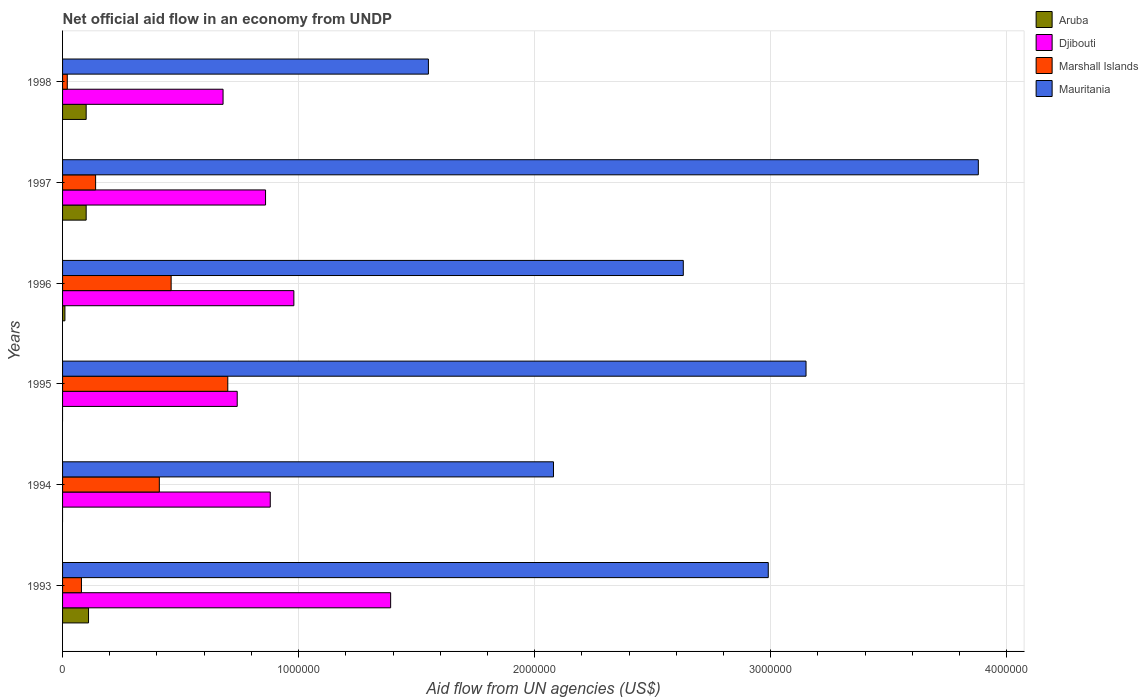How many different coloured bars are there?
Provide a succinct answer. 4. Are the number of bars on each tick of the Y-axis equal?
Give a very brief answer. No. In how many cases, is the number of bars for a given year not equal to the number of legend labels?
Make the answer very short. 2. What is the net official aid flow in Djibouti in 1994?
Give a very brief answer. 8.80e+05. Across all years, what is the maximum net official aid flow in Mauritania?
Your answer should be compact. 3.88e+06. Across all years, what is the minimum net official aid flow in Aruba?
Make the answer very short. 0. What is the total net official aid flow in Marshall Islands in the graph?
Make the answer very short. 1.81e+06. What is the difference between the net official aid flow in Marshall Islands in 1993 and that in 1994?
Keep it short and to the point. -3.30e+05. What is the difference between the net official aid flow in Mauritania in 1993 and the net official aid flow in Aruba in 1998?
Offer a very short reply. 2.89e+06. What is the average net official aid flow in Marshall Islands per year?
Your answer should be very brief. 3.02e+05. In the year 1993, what is the difference between the net official aid flow in Aruba and net official aid flow in Marshall Islands?
Give a very brief answer. 3.00e+04. What is the ratio of the net official aid flow in Djibouti in 1995 to that in 1997?
Ensure brevity in your answer.  0.86. What is the difference between the highest and the lowest net official aid flow in Djibouti?
Give a very brief answer. 7.10e+05. Is it the case that in every year, the sum of the net official aid flow in Aruba and net official aid flow in Mauritania is greater than the net official aid flow in Marshall Islands?
Your response must be concise. Yes. What is the difference between two consecutive major ticks on the X-axis?
Offer a terse response. 1.00e+06. Does the graph contain grids?
Your answer should be very brief. Yes. How many legend labels are there?
Your response must be concise. 4. What is the title of the graph?
Offer a very short reply. Net official aid flow in an economy from UNDP. Does "Sudan" appear as one of the legend labels in the graph?
Make the answer very short. No. What is the label or title of the X-axis?
Provide a succinct answer. Aid flow from UN agencies (US$). What is the label or title of the Y-axis?
Your answer should be very brief. Years. What is the Aid flow from UN agencies (US$) in Djibouti in 1993?
Your answer should be very brief. 1.39e+06. What is the Aid flow from UN agencies (US$) of Marshall Islands in 1993?
Your answer should be compact. 8.00e+04. What is the Aid flow from UN agencies (US$) in Mauritania in 1993?
Keep it short and to the point. 2.99e+06. What is the Aid flow from UN agencies (US$) in Aruba in 1994?
Provide a succinct answer. 0. What is the Aid flow from UN agencies (US$) in Djibouti in 1994?
Give a very brief answer. 8.80e+05. What is the Aid flow from UN agencies (US$) of Marshall Islands in 1994?
Keep it short and to the point. 4.10e+05. What is the Aid flow from UN agencies (US$) of Mauritania in 1994?
Your answer should be compact. 2.08e+06. What is the Aid flow from UN agencies (US$) of Djibouti in 1995?
Make the answer very short. 7.40e+05. What is the Aid flow from UN agencies (US$) in Mauritania in 1995?
Your answer should be very brief. 3.15e+06. What is the Aid flow from UN agencies (US$) in Djibouti in 1996?
Provide a succinct answer. 9.80e+05. What is the Aid flow from UN agencies (US$) of Marshall Islands in 1996?
Make the answer very short. 4.60e+05. What is the Aid flow from UN agencies (US$) of Mauritania in 1996?
Your response must be concise. 2.63e+06. What is the Aid flow from UN agencies (US$) in Djibouti in 1997?
Ensure brevity in your answer.  8.60e+05. What is the Aid flow from UN agencies (US$) in Marshall Islands in 1997?
Offer a very short reply. 1.40e+05. What is the Aid flow from UN agencies (US$) in Mauritania in 1997?
Your answer should be compact. 3.88e+06. What is the Aid flow from UN agencies (US$) of Aruba in 1998?
Give a very brief answer. 1.00e+05. What is the Aid flow from UN agencies (US$) of Djibouti in 1998?
Give a very brief answer. 6.80e+05. What is the Aid flow from UN agencies (US$) in Mauritania in 1998?
Make the answer very short. 1.55e+06. Across all years, what is the maximum Aid flow from UN agencies (US$) of Aruba?
Ensure brevity in your answer.  1.10e+05. Across all years, what is the maximum Aid flow from UN agencies (US$) of Djibouti?
Keep it short and to the point. 1.39e+06. Across all years, what is the maximum Aid flow from UN agencies (US$) of Marshall Islands?
Ensure brevity in your answer.  7.00e+05. Across all years, what is the maximum Aid flow from UN agencies (US$) in Mauritania?
Give a very brief answer. 3.88e+06. Across all years, what is the minimum Aid flow from UN agencies (US$) in Aruba?
Ensure brevity in your answer.  0. Across all years, what is the minimum Aid flow from UN agencies (US$) of Djibouti?
Offer a very short reply. 6.80e+05. Across all years, what is the minimum Aid flow from UN agencies (US$) of Marshall Islands?
Give a very brief answer. 2.00e+04. Across all years, what is the minimum Aid flow from UN agencies (US$) of Mauritania?
Your answer should be very brief. 1.55e+06. What is the total Aid flow from UN agencies (US$) of Djibouti in the graph?
Your answer should be compact. 5.53e+06. What is the total Aid flow from UN agencies (US$) of Marshall Islands in the graph?
Give a very brief answer. 1.81e+06. What is the total Aid flow from UN agencies (US$) in Mauritania in the graph?
Your response must be concise. 1.63e+07. What is the difference between the Aid flow from UN agencies (US$) in Djibouti in 1993 and that in 1994?
Provide a short and direct response. 5.10e+05. What is the difference between the Aid flow from UN agencies (US$) of Marshall Islands in 1993 and that in 1994?
Make the answer very short. -3.30e+05. What is the difference between the Aid flow from UN agencies (US$) of Mauritania in 1993 and that in 1994?
Your response must be concise. 9.10e+05. What is the difference between the Aid flow from UN agencies (US$) of Djibouti in 1993 and that in 1995?
Make the answer very short. 6.50e+05. What is the difference between the Aid flow from UN agencies (US$) of Marshall Islands in 1993 and that in 1995?
Offer a terse response. -6.20e+05. What is the difference between the Aid flow from UN agencies (US$) of Aruba in 1993 and that in 1996?
Ensure brevity in your answer.  1.00e+05. What is the difference between the Aid flow from UN agencies (US$) of Djibouti in 1993 and that in 1996?
Your response must be concise. 4.10e+05. What is the difference between the Aid flow from UN agencies (US$) in Marshall Islands in 1993 and that in 1996?
Your answer should be very brief. -3.80e+05. What is the difference between the Aid flow from UN agencies (US$) of Mauritania in 1993 and that in 1996?
Ensure brevity in your answer.  3.60e+05. What is the difference between the Aid flow from UN agencies (US$) in Aruba in 1993 and that in 1997?
Provide a succinct answer. 10000. What is the difference between the Aid flow from UN agencies (US$) in Djibouti in 1993 and that in 1997?
Provide a short and direct response. 5.30e+05. What is the difference between the Aid flow from UN agencies (US$) of Marshall Islands in 1993 and that in 1997?
Your answer should be very brief. -6.00e+04. What is the difference between the Aid flow from UN agencies (US$) of Mauritania in 1993 and that in 1997?
Keep it short and to the point. -8.90e+05. What is the difference between the Aid flow from UN agencies (US$) in Djibouti in 1993 and that in 1998?
Keep it short and to the point. 7.10e+05. What is the difference between the Aid flow from UN agencies (US$) of Mauritania in 1993 and that in 1998?
Your answer should be compact. 1.44e+06. What is the difference between the Aid flow from UN agencies (US$) in Djibouti in 1994 and that in 1995?
Keep it short and to the point. 1.40e+05. What is the difference between the Aid flow from UN agencies (US$) in Marshall Islands in 1994 and that in 1995?
Your answer should be compact. -2.90e+05. What is the difference between the Aid flow from UN agencies (US$) of Mauritania in 1994 and that in 1995?
Offer a very short reply. -1.07e+06. What is the difference between the Aid flow from UN agencies (US$) of Marshall Islands in 1994 and that in 1996?
Offer a very short reply. -5.00e+04. What is the difference between the Aid flow from UN agencies (US$) of Mauritania in 1994 and that in 1996?
Provide a short and direct response. -5.50e+05. What is the difference between the Aid flow from UN agencies (US$) in Marshall Islands in 1994 and that in 1997?
Offer a terse response. 2.70e+05. What is the difference between the Aid flow from UN agencies (US$) in Mauritania in 1994 and that in 1997?
Make the answer very short. -1.80e+06. What is the difference between the Aid flow from UN agencies (US$) of Djibouti in 1994 and that in 1998?
Give a very brief answer. 2.00e+05. What is the difference between the Aid flow from UN agencies (US$) of Marshall Islands in 1994 and that in 1998?
Your answer should be compact. 3.90e+05. What is the difference between the Aid flow from UN agencies (US$) of Mauritania in 1994 and that in 1998?
Keep it short and to the point. 5.30e+05. What is the difference between the Aid flow from UN agencies (US$) in Marshall Islands in 1995 and that in 1996?
Your answer should be compact. 2.40e+05. What is the difference between the Aid flow from UN agencies (US$) of Mauritania in 1995 and that in 1996?
Make the answer very short. 5.20e+05. What is the difference between the Aid flow from UN agencies (US$) in Marshall Islands in 1995 and that in 1997?
Offer a terse response. 5.60e+05. What is the difference between the Aid flow from UN agencies (US$) in Mauritania in 1995 and that in 1997?
Give a very brief answer. -7.30e+05. What is the difference between the Aid flow from UN agencies (US$) of Marshall Islands in 1995 and that in 1998?
Offer a very short reply. 6.80e+05. What is the difference between the Aid flow from UN agencies (US$) in Mauritania in 1995 and that in 1998?
Your response must be concise. 1.60e+06. What is the difference between the Aid flow from UN agencies (US$) in Aruba in 1996 and that in 1997?
Offer a terse response. -9.00e+04. What is the difference between the Aid flow from UN agencies (US$) of Djibouti in 1996 and that in 1997?
Provide a succinct answer. 1.20e+05. What is the difference between the Aid flow from UN agencies (US$) of Mauritania in 1996 and that in 1997?
Keep it short and to the point. -1.25e+06. What is the difference between the Aid flow from UN agencies (US$) of Djibouti in 1996 and that in 1998?
Give a very brief answer. 3.00e+05. What is the difference between the Aid flow from UN agencies (US$) of Marshall Islands in 1996 and that in 1998?
Your answer should be compact. 4.40e+05. What is the difference between the Aid flow from UN agencies (US$) in Mauritania in 1996 and that in 1998?
Offer a terse response. 1.08e+06. What is the difference between the Aid flow from UN agencies (US$) in Aruba in 1997 and that in 1998?
Your answer should be very brief. 0. What is the difference between the Aid flow from UN agencies (US$) of Mauritania in 1997 and that in 1998?
Provide a succinct answer. 2.33e+06. What is the difference between the Aid flow from UN agencies (US$) in Aruba in 1993 and the Aid flow from UN agencies (US$) in Djibouti in 1994?
Offer a terse response. -7.70e+05. What is the difference between the Aid flow from UN agencies (US$) of Aruba in 1993 and the Aid flow from UN agencies (US$) of Mauritania in 1994?
Provide a short and direct response. -1.97e+06. What is the difference between the Aid flow from UN agencies (US$) in Djibouti in 1993 and the Aid flow from UN agencies (US$) in Marshall Islands in 1994?
Offer a very short reply. 9.80e+05. What is the difference between the Aid flow from UN agencies (US$) in Djibouti in 1993 and the Aid flow from UN agencies (US$) in Mauritania in 1994?
Provide a short and direct response. -6.90e+05. What is the difference between the Aid flow from UN agencies (US$) in Aruba in 1993 and the Aid flow from UN agencies (US$) in Djibouti in 1995?
Offer a terse response. -6.30e+05. What is the difference between the Aid flow from UN agencies (US$) of Aruba in 1993 and the Aid flow from UN agencies (US$) of Marshall Islands in 1995?
Your response must be concise. -5.90e+05. What is the difference between the Aid flow from UN agencies (US$) of Aruba in 1993 and the Aid flow from UN agencies (US$) of Mauritania in 1995?
Your response must be concise. -3.04e+06. What is the difference between the Aid flow from UN agencies (US$) of Djibouti in 1993 and the Aid flow from UN agencies (US$) of Marshall Islands in 1995?
Your answer should be compact. 6.90e+05. What is the difference between the Aid flow from UN agencies (US$) in Djibouti in 1993 and the Aid flow from UN agencies (US$) in Mauritania in 1995?
Provide a succinct answer. -1.76e+06. What is the difference between the Aid flow from UN agencies (US$) in Marshall Islands in 1993 and the Aid flow from UN agencies (US$) in Mauritania in 1995?
Your answer should be compact. -3.07e+06. What is the difference between the Aid flow from UN agencies (US$) of Aruba in 1993 and the Aid flow from UN agencies (US$) of Djibouti in 1996?
Your answer should be compact. -8.70e+05. What is the difference between the Aid flow from UN agencies (US$) in Aruba in 1993 and the Aid flow from UN agencies (US$) in Marshall Islands in 1996?
Provide a short and direct response. -3.50e+05. What is the difference between the Aid flow from UN agencies (US$) of Aruba in 1993 and the Aid flow from UN agencies (US$) of Mauritania in 1996?
Provide a succinct answer. -2.52e+06. What is the difference between the Aid flow from UN agencies (US$) in Djibouti in 1993 and the Aid flow from UN agencies (US$) in Marshall Islands in 1996?
Make the answer very short. 9.30e+05. What is the difference between the Aid flow from UN agencies (US$) of Djibouti in 1993 and the Aid flow from UN agencies (US$) of Mauritania in 1996?
Your response must be concise. -1.24e+06. What is the difference between the Aid flow from UN agencies (US$) in Marshall Islands in 1993 and the Aid flow from UN agencies (US$) in Mauritania in 1996?
Your response must be concise. -2.55e+06. What is the difference between the Aid flow from UN agencies (US$) in Aruba in 1993 and the Aid flow from UN agencies (US$) in Djibouti in 1997?
Offer a terse response. -7.50e+05. What is the difference between the Aid flow from UN agencies (US$) in Aruba in 1993 and the Aid flow from UN agencies (US$) in Marshall Islands in 1997?
Provide a succinct answer. -3.00e+04. What is the difference between the Aid flow from UN agencies (US$) of Aruba in 1993 and the Aid flow from UN agencies (US$) of Mauritania in 1997?
Ensure brevity in your answer.  -3.77e+06. What is the difference between the Aid flow from UN agencies (US$) of Djibouti in 1993 and the Aid flow from UN agencies (US$) of Marshall Islands in 1997?
Keep it short and to the point. 1.25e+06. What is the difference between the Aid flow from UN agencies (US$) in Djibouti in 1993 and the Aid flow from UN agencies (US$) in Mauritania in 1997?
Your response must be concise. -2.49e+06. What is the difference between the Aid flow from UN agencies (US$) of Marshall Islands in 1993 and the Aid flow from UN agencies (US$) of Mauritania in 1997?
Offer a terse response. -3.80e+06. What is the difference between the Aid flow from UN agencies (US$) of Aruba in 1993 and the Aid flow from UN agencies (US$) of Djibouti in 1998?
Ensure brevity in your answer.  -5.70e+05. What is the difference between the Aid flow from UN agencies (US$) in Aruba in 1993 and the Aid flow from UN agencies (US$) in Marshall Islands in 1998?
Offer a very short reply. 9.00e+04. What is the difference between the Aid flow from UN agencies (US$) in Aruba in 1993 and the Aid flow from UN agencies (US$) in Mauritania in 1998?
Your answer should be very brief. -1.44e+06. What is the difference between the Aid flow from UN agencies (US$) in Djibouti in 1993 and the Aid flow from UN agencies (US$) in Marshall Islands in 1998?
Give a very brief answer. 1.37e+06. What is the difference between the Aid flow from UN agencies (US$) of Marshall Islands in 1993 and the Aid flow from UN agencies (US$) of Mauritania in 1998?
Provide a succinct answer. -1.47e+06. What is the difference between the Aid flow from UN agencies (US$) of Djibouti in 1994 and the Aid flow from UN agencies (US$) of Mauritania in 1995?
Offer a very short reply. -2.27e+06. What is the difference between the Aid flow from UN agencies (US$) in Marshall Islands in 1994 and the Aid flow from UN agencies (US$) in Mauritania in 1995?
Your answer should be compact. -2.74e+06. What is the difference between the Aid flow from UN agencies (US$) of Djibouti in 1994 and the Aid flow from UN agencies (US$) of Mauritania in 1996?
Give a very brief answer. -1.75e+06. What is the difference between the Aid flow from UN agencies (US$) in Marshall Islands in 1994 and the Aid flow from UN agencies (US$) in Mauritania in 1996?
Your answer should be very brief. -2.22e+06. What is the difference between the Aid flow from UN agencies (US$) in Djibouti in 1994 and the Aid flow from UN agencies (US$) in Marshall Islands in 1997?
Offer a terse response. 7.40e+05. What is the difference between the Aid flow from UN agencies (US$) of Marshall Islands in 1994 and the Aid flow from UN agencies (US$) of Mauritania in 1997?
Ensure brevity in your answer.  -3.47e+06. What is the difference between the Aid flow from UN agencies (US$) of Djibouti in 1994 and the Aid flow from UN agencies (US$) of Marshall Islands in 1998?
Provide a succinct answer. 8.60e+05. What is the difference between the Aid flow from UN agencies (US$) in Djibouti in 1994 and the Aid flow from UN agencies (US$) in Mauritania in 1998?
Offer a very short reply. -6.70e+05. What is the difference between the Aid flow from UN agencies (US$) of Marshall Islands in 1994 and the Aid flow from UN agencies (US$) of Mauritania in 1998?
Your response must be concise. -1.14e+06. What is the difference between the Aid flow from UN agencies (US$) in Djibouti in 1995 and the Aid flow from UN agencies (US$) in Marshall Islands in 1996?
Provide a succinct answer. 2.80e+05. What is the difference between the Aid flow from UN agencies (US$) of Djibouti in 1995 and the Aid flow from UN agencies (US$) of Mauritania in 1996?
Your answer should be very brief. -1.89e+06. What is the difference between the Aid flow from UN agencies (US$) of Marshall Islands in 1995 and the Aid flow from UN agencies (US$) of Mauritania in 1996?
Keep it short and to the point. -1.93e+06. What is the difference between the Aid flow from UN agencies (US$) in Djibouti in 1995 and the Aid flow from UN agencies (US$) in Mauritania in 1997?
Provide a succinct answer. -3.14e+06. What is the difference between the Aid flow from UN agencies (US$) of Marshall Islands in 1995 and the Aid flow from UN agencies (US$) of Mauritania in 1997?
Give a very brief answer. -3.18e+06. What is the difference between the Aid flow from UN agencies (US$) in Djibouti in 1995 and the Aid flow from UN agencies (US$) in Marshall Islands in 1998?
Ensure brevity in your answer.  7.20e+05. What is the difference between the Aid flow from UN agencies (US$) in Djibouti in 1995 and the Aid flow from UN agencies (US$) in Mauritania in 1998?
Offer a very short reply. -8.10e+05. What is the difference between the Aid flow from UN agencies (US$) of Marshall Islands in 1995 and the Aid flow from UN agencies (US$) of Mauritania in 1998?
Provide a short and direct response. -8.50e+05. What is the difference between the Aid flow from UN agencies (US$) in Aruba in 1996 and the Aid flow from UN agencies (US$) in Djibouti in 1997?
Your response must be concise. -8.50e+05. What is the difference between the Aid flow from UN agencies (US$) in Aruba in 1996 and the Aid flow from UN agencies (US$) in Mauritania in 1997?
Offer a very short reply. -3.87e+06. What is the difference between the Aid flow from UN agencies (US$) of Djibouti in 1996 and the Aid flow from UN agencies (US$) of Marshall Islands in 1997?
Keep it short and to the point. 8.40e+05. What is the difference between the Aid flow from UN agencies (US$) in Djibouti in 1996 and the Aid flow from UN agencies (US$) in Mauritania in 1997?
Ensure brevity in your answer.  -2.90e+06. What is the difference between the Aid flow from UN agencies (US$) in Marshall Islands in 1996 and the Aid flow from UN agencies (US$) in Mauritania in 1997?
Provide a short and direct response. -3.42e+06. What is the difference between the Aid flow from UN agencies (US$) of Aruba in 1996 and the Aid flow from UN agencies (US$) of Djibouti in 1998?
Give a very brief answer. -6.70e+05. What is the difference between the Aid flow from UN agencies (US$) in Aruba in 1996 and the Aid flow from UN agencies (US$) in Mauritania in 1998?
Provide a short and direct response. -1.54e+06. What is the difference between the Aid flow from UN agencies (US$) of Djibouti in 1996 and the Aid flow from UN agencies (US$) of Marshall Islands in 1998?
Your answer should be very brief. 9.60e+05. What is the difference between the Aid flow from UN agencies (US$) of Djibouti in 1996 and the Aid flow from UN agencies (US$) of Mauritania in 1998?
Give a very brief answer. -5.70e+05. What is the difference between the Aid flow from UN agencies (US$) of Marshall Islands in 1996 and the Aid flow from UN agencies (US$) of Mauritania in 1998?
Make the answer very short. -1.09e+06. What is the difference between the Aid flow from UN agencies (US$) of Aruba in 1997 and the Aid flow from UN agencies (US$) of Djibouti in 1998?
Provide a short and direct response. -5.80e+05. What is the difference between the Aid flow from UN agencies (US$) in Aruba in 1997 and the Aid flow from UN agencies (US$) in Marshall Islands in 1998?
Give a very brief answer. 8.00e+04. What is the difference between the Aid flow from UN agencies (US$) of Aruba in 1997 and the Aid flow from UN agencies (US$) of Mauritania in 1998?
Keep it short and to the point. -1.45e+06. What is the difference between the Aid flow from UN agencies (US$) in Djibouti in 1997 and the Aid flow from UN agencies (US$) in Marshall Islands in 1998?
Make the answer very short. 8.40e+05. What is the difference between the Aid flow from UN agencies (US$) of Djibouti in 1997 and the Aid flow from UN agencies (US$) of Mauritania in 1998?
Your response must be concise. -6.90e+05. What is the difference between the Aid flow from UN agencies (US$) of Marshall Islands in 1997 and the Aid flow from UN agencies (US$) of Mauritania in 1998?
Offer a terse response. -1.41e+06. What is the average Aid flow from UN agencies (US$) in Aruba per year?
Your answer should be very brief. 5.33e+04. What is the average Aid flow from UN agencies (US$) in Djibouti per year?
Offer a very short reply. 9.22e+05. What is the average Aid flow from UN agencies (US$) in Marshall Islands per year?
Make the answer very short. 3.02e+05. What is the average Aid flow from UN agencies (US$) in Mauritania per year?
Offer a very short reply. 2.71e+06. In the year 1993, what is the difference between the Aid flow from UN agencies (US$) of Aruba and Aid flow from UN agencies (US$) of Djibouti?
Your answer should be compact. -1.28e+06. In the year 1993, what is the difference between the Aid flow from UN agencies (US$) of Aruba and Aid flow from UN agencies (US$) of Marshall Islands?
Your answer should be compact. 3.00e+04. In the year 1993, what is the difference between the Aid flow from UN agencies (US$) of Aruba and Aid flow from UN agencies (US$) of Mauritania?
Give a very brief answer. -2.88e+06. In the year 1993, what is the difference between the Aid flow from UN agencies (US$) of Djibouti and Aid flow from UN agencies (US$) of Marshall Islands?
Your answer should be very brief. 1.31e+06. In the year 1993, what is the difference between the Aid flow from UN agencies (US$) in Djibouti and Aid flow from UN agencies (US$) in Mauritania?
Offer a very short reply. -1.60e+06. In the year 1993, what is the difference between the Aid flow from UN agencies (US$) of Marshall Islands and Aid flow from UN agencies (US$) of Mauritania?
Make the answer very short. -2.91e+06. In the year 1994, what is the difference between the Aid flow from UN agencies (US$) of Djibouti and Aid flow from UN agencies (US$) of Mauritania?
Offer a terse response. -1.20e+06. In the year 1994, what is the difference between the Aid flow from UN agencies (US$) of Marshall Islands and Aid flow from UN agencies (US$) of Mauritania?
Provide a succinct answer. -1.67e+06. In the year 1995, what is the difference between the Aid flow from UN agencies (US$) in Djibouti and Aid flow from UN agencies (US$) in Mauritania?
Ensure brevity in your answer.  -2.41e+06. In the year 1995, what is the difference between the Aid flow from UN agencies (US$) of Marshall Islands and Aid flow from UN agencies (US$) of Mauritania?
Keep it short and to the point. -2.45e+06. In the year 1996, what is the difference between the Aid flow from UN agencies (US$) of Aruba and Aid flow from UN agencies (US$) of Djibouti?
Your response must be concise. -9.70e+05. In the year 1996, what is the difference between the Aid flow from UN agencies (US$) in Aruba and Aid flow from UN agencies (US$) in Marshall Islands?
Provide a short and direct response. -4.50e+05. In the year 1996, what is the difference between the Aid flow from UN agencies (US$) in Aruba and Aid flow from UN agencies (US$) in Mauritania?
Your answer should be compact. -2.62e+06. In the year 1996, what is the difference between the Aid flow from UN agencies (US$) of Djibouti and Aid flow from UN agencies (US$) of Marshall Islands?
Ensure brevity in your answer.  5.20e+05. In the year 1996, what is the difference between the Aid flow from UN agencies (US$) of Djibouti and Aid flow from UN agencies (US$) of Mauritania?
Your response must be concise. -1.65e+06. In the year 1996, what is the difference between the Aid flow from UN agencies (US$) in Marshall Islands and Aid flow from UN agencies (US$) in Mauritania?
Provide a succinct answer. -2.17e+06. In the year 1997, what is the difference between the Aid flow from UN agencies (US$) of Aruba and Aid flow from UN agencies (US$) of Djibouti?
Provide a short and direct response. -7.60e+05. In the year 1997, what is the difference between the Aid flow from UN agencies (US$) of Aruba and Aid flow from UN agencies (US$) of Mauritania?
Ensure brevity in your answer.  -3.78e+06. In the year 1997, what is the difference between the Aid flow from UN agencies (US$) of Djibouti and Aid flow from UN agencies (US$) of Marshall Islands?
Keep it short and to the point. 7.20e+05. In the year 1997, what is the difference between the Aid flow from UN agencies (US$) of Djibouti and Aid flow from UN agencies (US$) of Mauritania?
Provide a succinct answer. -3.02e+06. In the year 1997, what is the difference between the Aid flow from UN agencies (US$) of Marshall Islands and Aid flow from UN agencies (US$) of Mauritania?
Your response must be concise. -3.74e+06. In the year 1998, what is the difference between the Aid flow from UN agencies (US$) of Aruba and Aid flow from UN agencies (US$) of Djibouti?
Provide a short and direct response. -5.80e+05. In the year 1998, what is the difference between the Aid flow from UN agencies (US$) of Aruba and Aid flow from UN agencies (US$) of Mauritania?
Make the answer very short. -1.45e+06. In the year 1998, what is the difference between the Aid flow from UN agencies (US$) of Djibouti and Aid flow from UN agencies (US$) of Marshall Islands?
Give a very brief answer. 6.60e+05. In the year 1998, what is the difference between the Aid flow from UN agencies (US$) in Djibouti and Aid flow from UN agencies (US$) in Mauritania?
Your response must be concise. -8.70e+05. In the year 1998, what is the difference between the Aid flow from UN agencies (US$) of Marshall Islands and Aid flow from UN agencies (US$) of Mauritania?
Keep it short and to the point. -1.53e+06. What is the ratio of the Aid flow from UN agencies (US$) in Djibouti in 1993 to that in 1994?
Keep it short and to the point. 1.58. What is the ratio of the Aid flow from UN agencies (US$) of Marshall Islands in 1993 to that in 1994?
Give a very brief answer. 0.2. What is the ratio of the Aid flow from UN agencies (US$) of Mauritania in 1993 to that in 1994?
Provide a short and direct response. 1.44. What is the ratio of the Aid flow from UN agencies (US$) of Djibouti in 1993 to that in 1995?
Your answer should be compact. 1.88. What is the ratio of the Aid flow from UN agencies (US$) in Marshall Islands in 1993 to that in 1995?
Your answer should be very brief. 0.11. What is the ratio of the Aid flow from UN agencies (US$) of Mauritania in 1993 to that in 1995?
Ensure brevity in your answer.  0.95. What is the ratio of the Aid flow from UN agencies (US$) of Aruba in 1993 to that in 1996?
Provide a succinct answer. 11. What is the ratio of the Aid flow from UN agencies (US$) of Djibouti in 1993 to that in 1996?
Your answer should be compact. 1.42. What is the ratio of the Aid flow from UN agencies (US$) in Marshall Islands in 1993 to that in 1996?
Your response must be concise. 0.17. What is the ratio of the Aid flow from UN agencies (US$) in Mauritania in 1993 to that in 1996?
Ensure brevity in your answer.  1.14. What is the ratio of the Aid flow from UN agencies (US$) of Djibouti in 1993 to that in 1997?
Your answer should be compact. 1.62. What is the ratio of the Aid flow from UN agencies (US$) of Mauritania in 1993 to that in 1997?
Your response must be concise. 0.77. What is the ratio of the Aid flow from UN agencies (US$) in Djibouti in 1993 to that in 1998?
Offer a very short reply. 2.04. What is the ratio of the Aid flow from UN agencies (US$) of Marshall Islands in 1993 to that in 1998?
Offer a very short reply. 4. What is the ratio of the Aid flow from UN agencies (US$) of Mauritania in 1993 to that in 1998?
Your answer should be very brief. 1.93. What is the ratio of the Aid flow from UN agencies (US$) of Djibouti in 1994 to that in 1995?
Ensure brevity in your answer.  1.19. What is the ratio of the Aid flow from UN agencies (US$) of Marshall Islands in 1994 to that in 1995?
Offer a terse response. 0.59. What is the ratio of the Aid flow from UN agencies (US$) in Mauritania in 1994 to that in 1995?
Your answer should be very brief. 0.66. What is the ratio of the Aid flow from UN agencies (US$) in Djibouti in 1994 to that in 1996?
Your answer should be very brief. 0.9. What is the ratio of the Aid flow from UN agencies (US$) of Marshall Islands in 1994 to that in 1996?
Keep it short and to the point. 0.89. What is the ratio of the Aid flow from UN agencies (US$) of Mauritania in 1994 to that in 1996?
Offer a very short reply. 0.79. What is the ratio of the Aid flow from UN agencies (US$) in Djibouti in 1994 to that in 1997?
Your answer should be very brief. 1.02. What is the ratio of the Aid flow from UN agencies (US$) in Marshall Islands in 1994 to that in 1997?
Your response must be concise. 2.93. What is the ratio of the Aid flow from UN agencies (US$) of Mauritania in 1994 to that in 1997?
Provide a succinct answer. 0.54. What is the ratio of the Aid flow from UN agencies (US$) in Djibouti in 1994 to that in 1998?
Your answer should be very brief. 1.29. What is the ratio of the Aid flow from UN agencies (US$) of Mauritania in 1994 to that in 1998?
Offer a terse response. 1.34. What is the ratio of the Aid flow from UN agencies (US$) of Djibouti in 1995 to that in 1996?
Make the answer very short. 0.76. What is the ratio of the Aid flow from UN agencies (US$) of Marshall Islands in 1995 to that in 1996?
Your answer should be very brief. 1.52. What is the ratio of the Aid flow from UN agencies (US$) of Mauritania in 1995 to that in 1996?
Offer a very short reply. 1.2. What is the ratio of the Aid flow from UN agencies (US$) in Djibouti in 1995 to that in 1997?
Provide a succinct answer. 0.86. What is the ratio of the Aid flow from UN agencies (US$) of Marshall Islands in 1995 to that in 1997?
Offer a very short reply. 5. What is the ratio of the Aid flow from UN agencies (US$) in Mauritania in 1995 to that in 1997?
Keep it short and to the point. 0.81. What is the ratio of the Aid flow from UN agencies (US$) in Djibouti in 1995 to that in 1998?
Your response must be concise. 1.09. What is the ratio of the Aid flow from UN agencies (US$) in Mauritania in 1995 to that in 1998?
Your response must be concise. 2.03. What is the ratio of the Aid flow from UN agencies (US$) of Djibouti in 1996 to that in 1997?
Your answer should be very brief. 1.14. What is the ratio of the Aid flow from UN agencies (US$) in Marshall Islands in 1996 to that in 1997?
Give a very brief answer. 3.29. What is the ratio of the Aid flow from UN agencies (US$) in Mauritania in 1996 to that in 1997?
Provide a succinct answer. 0.68. What is the ratio of the Aid flow from UN agencies (US$) of Djibouti in 1996 to that in 1998?
Your answer should be compact. 1.44. What is the ratio of the Aid flow from UN agencies (US$) of Mauritania in 1996 to that in 1998?
Your answer should be very brief. 1.7. What is the ratio of the Aid flow from UN agencies (US$) of Djibouti in 1997 to that in 1998?
Provide a short and direct response. 1.26. What is the ratio of the Aid flow from UN agencies (US$) in Mauritania in 1997 to that in 1998?
Offer a terse response. 2.5. What is the difference between the highest and the second highest Aid flow from UN agencies (US$) of Aruba?
Give a very brief answer. 10000. What is the difference between the highest and the second highest Aid flow from UN agencies (US$) in Marshall Islands?
Your answer should be very brief. 2.40e+05. What is the difference between the highest and the second highest Aid flow from UN agencies (US$) of Mauritania?
Offer a very short reply. 7.30e+05. What is the difference between the highest and the lowest Aid flow from UN agencies (US$) in Aruba?
Your answer should be compact. 1.10e+05. What is the difference between the highest and the lowest Aid flow from UN agencies (US$) in Djibouti?
Keep it short and to the point. 7.10e+05. What is the difference between the highest and the lowest Aid flow from UN agencies (US$) of Marshall Islands?
Offer a very short reply. 6.80e+05. What is the difference between the highest and the lowest Aid flow from UN agencies (US$) in Mauritania?
Offer a terse response. 2.33e+06. 